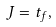Convert formula to latex. <formula><loc_0><loc_0><loc_500><loc_500>J = t _ { f } ,</formula> 